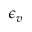Convert formula to latex. <formula><loc_0><loc_0><loc_500><loc_500>\epsilon _ { v }</formula> 